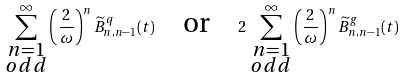<formula> <loc_0><loc_0><loc_500><loc_500>\sum _ { \substack { n = 1 \\ { o d d } } } ^ { \infty } \left ( \frac { 2 } { \omega } \right ) ^ { n } \widetilde { B } ^ { q } _ { n , n - 1 } ( t ) \quad \text {or} \quad 2 \, \sum _ { \substack { n = 1 \\ { o d d } } } ^ { \infty } \left ( \frac { 2 } { \omega } \right ) ^ { n } \widetilde { B } ^ { g } _ { n , n - 1 } ( t )</formula> 